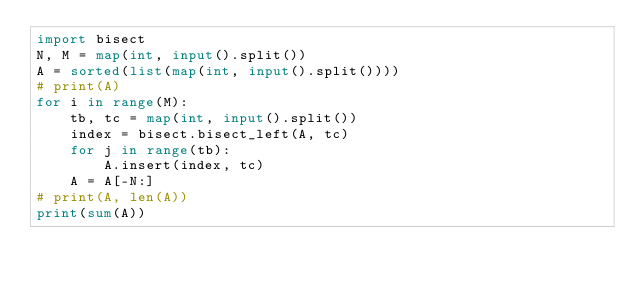Convert code to text. <code><loc_0><loc_0><loc_500><loc_500><_Python_>import bisect
N, M = map(int, input().split())
A = sorted(list(map(int, input().split())))
# print(A)
for i in range(M):
    tb, tc = map(int, input().split())
    index = bisect.bisect_left(A, tc)
    for j in range(tb):
        A.insert(index, tc)
    A = A[-N:]
# print(A, len(A))
print(sum(A))
</code> 